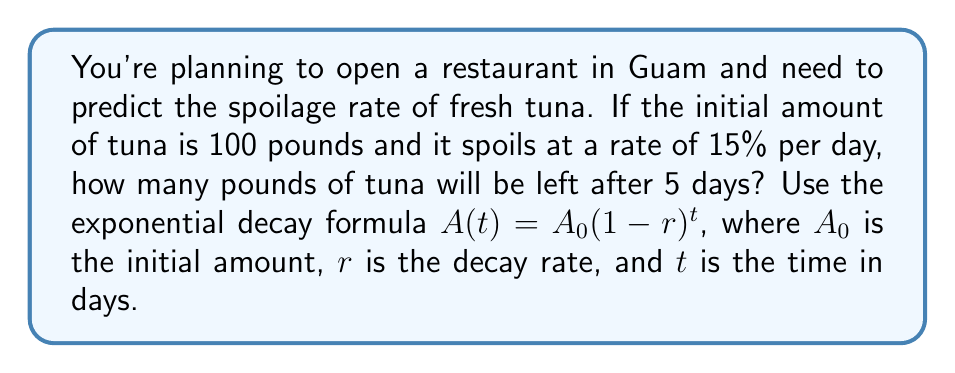Teach me how to tackle this problem. Let's solve this problem step-by-step using the exponential decay formula:

1) We're given:
   $A_0 = 100$ pounds (initial amount of tuna)
   $r = 15\% = 0.15$ (decay rate per day)
   $t = 5$ days

2) The exponential decay formula is:
   $A(t) = A_0(1-r)^t$

3) Substituting our values:
   $A(5) = 100(1-0.15)^5$

4) Simplify inside the parentheses:
   $A(5) = 100(0.85)^5$

5) Calculate $(0.85)^5$:
   $(0.85)^5 \approx 0.4437$

6) Multiply by 100:
   $A(5) = 100 * 0.4437 \approx 44.37$

Therefore, after 5 days, approximately 44.37 pounds of tuna will be left.
Answer: 44.37 pounds 